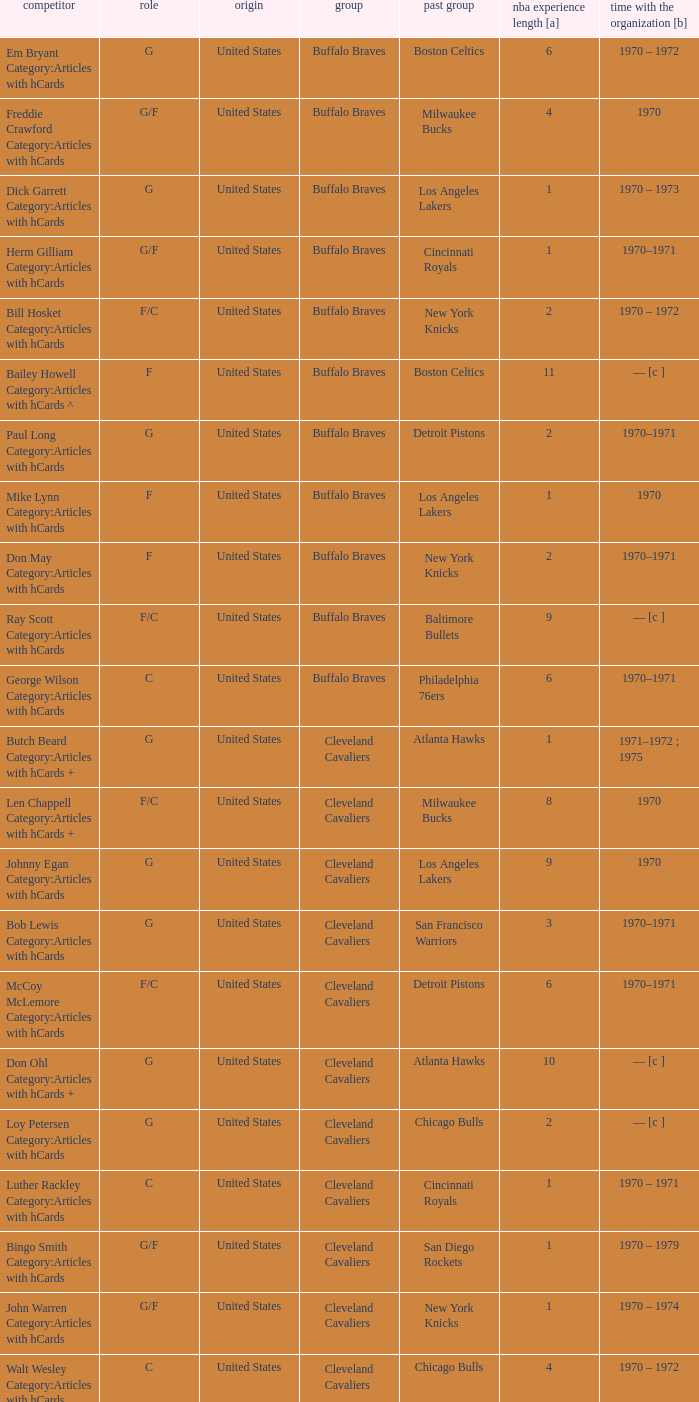How many years of NBA experience does the player who plays position g for the Portland Trail Blazers? 2.0. 